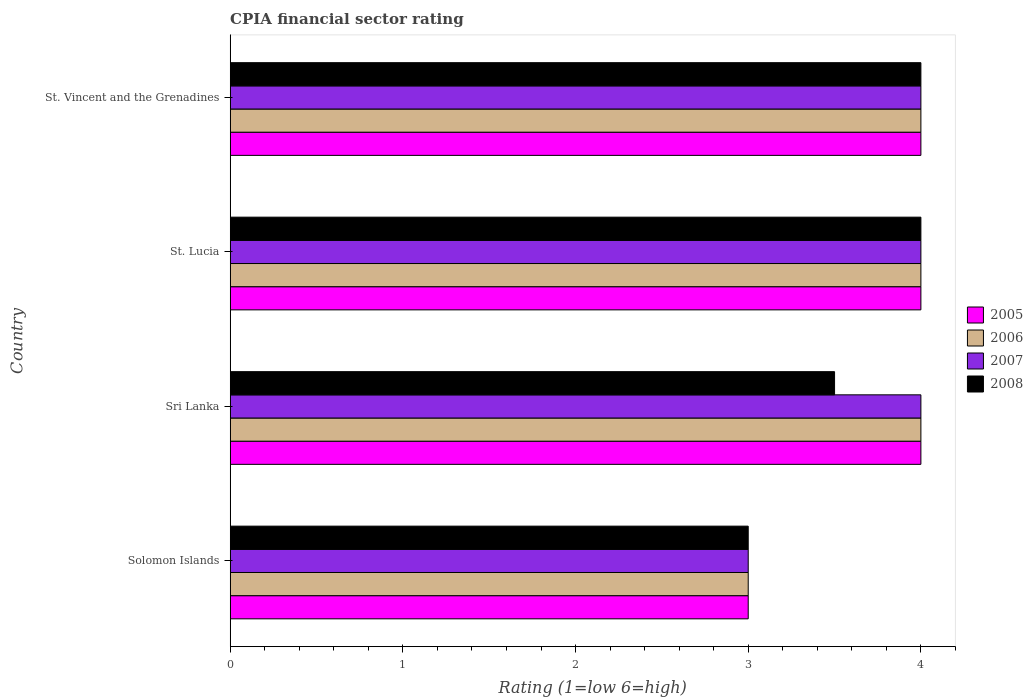Are the number of bars per tick equal to the number of legend labels?
Your response must be concise. Yes. How many bars are there on the 3rd tick from the top?
Your answer should be compact. 4. What is the label of the 2nd group of bars from the top?
Provide a short and direct response. St. Lucia. In how many cases, is the number of bars for a given country not equal to the number of legend labels?
Provide a succinct answer. 0. What is the CPIA rating in 2007 in St. Vincent and the Grenadines?
Provide a succinct answer. 4. In which country was the CPIA rating in 2008 maximum?
Ensure brevity in your answer.  St. Lucia. In which country was the CPIA rating in 2007 minimum?
Give a very brief answer. Solomon Islands. What is the average CPIA rating in 2006 per country?
Provide a short and direct response. 3.75. What is the difference between the CPIA rating in 2005 and CPIA rating in 2008 in St. Vincent and the Grenadines?
Keep it short and to the point. 0. In how many countries, is the CPIA rating in 2006 greater than 2.2 ?
Ensure brevity in your answer.  4. Is the CPIA rating in 2006 in Solomon Islands less than that in Sri Lanka?
Keep it short and to the point. Yes. Is the difference between the CPIA rating in 2005 in St. Lucia and St. Vincent and the Grenadines greater than the difference between the CPIA rating in 2008 in St. Lucia and St. Vincent and the Grenadines?
Your response must be concise. No. What is the difference between the highest and the second highest CPIA rating in 2006?
Offer a terse response. 0. What is the difference between the highest and the lowest CPIA rating in 2008?
Your answer should be very brief. 1. Is the sum of the CPIA rating in 2005 in Solomon Islands and Sri Lanka greater than the maximum CPIA rating in 2006 across all countries?
Give a very brief answer. Yes. Is it the case that in every country, the sum of the CPIA rating in 2006 and CPIA rating in 2008 is greater than the sum of CPIA rating in 2007 and CPIA rating in 2005?
Ensure brevity in your answer.  No. What does the 4th bar from the bottom in St. Lucia represents?
Provide a short and direct response. 2008. How many bars are there?
Your response must be concise. 16. Are all the bars in the graph horizontal?
Offer a very short reply. Yes. How many countries are there in the graph?
Provide a succinct answer. 4. What is the difference between two consecutive major ticks on the X-axis?
Your answer should be compact. 1. Where does the legend appear in the graph?
Your response must be concise. Center right. How many legend labels are there?
Ensure brevity in your answer.  4. What is the title of the graph?
Offer a terse response. CPIA financial sector rating. Does "2002" appear as one of the legend labels in the graph?
Your answer should be compact. No. What is the label or title of the X-axis?
Make the answer very short. Rating (1=low 6=high). What is the Rating (1=low 6=high) in 2005 in Solomon Islands?
Give a very brief answer. 3. What is the Rating (1=low 6=high) of 2006 in Solomon Islands?
Provide a succinct answer. 3. What is the Rating (1=low 6=high) in 2007 in Solomon Islands?
Offer a terse response. 3. What is the Rating (1=low 6=high) in 2006 in Sri Lanka?
Give a very brief answer. 4. What is the Rating (1=low 6=high) of 2005 in St. Lucia?
Make the answer very short. 4. What is the Rating (1=low 6=high) of 2007 in St. Lucia?
Offer a very short reply. 4. What is the Rating (1=low 6=high) in 2006 in St. Vincent and the Grenadines?
Your answer should be very brief. 4. What is the Rating (1=low 6=high) of 2007 in St. Vincent and the Grenadines?
Offer a very short reply. 4. Across all countries, what is the maximum Rating (1=low 6=high) in 2006?
Your answer should be compact. 4. Across all countries, what is the maximum Rating (1=low 6=high) in 2007?
Ensure brevity in your answer.  4. Across all countries, what is the maximum Rating (1=low 6=high) of 2008?
Offer a terse response. 4. Across all countries, what is the minimum Rating (1=low 6=high) of 2005?
Keep it short and to the point. 3. Across all countries, what is the minimum Rating (1=low 6=high) of 2006?
Your response must be concise. 3. Across all countries, what is the minimum Rating (1=low 6=high) of 2008?
Your answer should be compact. 3. What is the total Rating (1=low 6=high) of 2006 in the graph?
Ensure brevity in your answer.  15. What is the difference between the Rating (1=low 6=high) of 2006 in Solomon Islands and that in Sri Lanka?
Keep it short and to the point. -1. What is the difference between the Rating (1=low 6=high) in 2007 in Solomon Islands and that in St. Lucia?
Make the answer very short. -1. What is the difference between the Rating (1=low 6=high) of 2007 in Solomon Islands and that in St. Vincent and the Grenadines?
Offer a terse response. -1. What is the difference between the Rating (1=low 6=high) of 2007 in Sri Lanka and that in St. Lucia?
Offer a very short reply. 0. What is the difference between the Rating (1=low 6=high) of 2008 in Sri Lanka and that in St. Lucia?
Keep it short and to the point. -0.5. What is the difference between the Rating (1=low 6=high) in 2005 in Sri Lanka and that in St. Vincent and the Grenadines?
Ensure brevity in your answer.  0. What is the difference between the Rating (1=low 6=high) in 2007 in Sri Lanka and that in St. Vincent and the Grenadines?
Ensure brevity in your answer.  0. What is the difference between the Rating (1=low 6=high) of 2008 in Sri Lanka and that in St. Vincent and the Grenadines?
Make the answer very short. -0.5. What is the difference between the Rating (1=low 6=high) of 2007 in St. Lucia and that in St. Vincent and the Grenadines?
Your answer should be compact. 0. What is the difference between the Rating (1=low 6=high) in 2008 in St. Lucia and that in St. Vincent and the Grenadines?
Give a very brief answer. 0. What is the difference between the Rating (1=low 6=high) of 2005 in Solomon Islands and the Rating (1=low 6=high) of 2007 in Sri Lanka?
Your answer should be very brief. -1. What is the difference between the Rating (1=low 6=high) in 2005 in Solomon Islands and the Rating (1=low 6=high) in 2008 in Sri Lanka?
Ensure brevity in your answer.  -0.5. What is the difference between the Rating (1=low 6=high) of 2006 in Solomon Islands and the Rating (1=low 6=high) of 2008 in Sri Lanka?
Make the answer very short. -0.5. What is the difference between the Rating (1=low 6=high) of 2005 in Solomon Islands and the Rating (1=low 6=high) of 2007 in St. Lucia?
Keep it short and to the point. -1. What is the difference between the Rating (1=low 6=high) of 2006 in Solomon Islands and the Rating (1=low 6=high) of 2007 in St. Lucia?
Your response must be concise. -1. What is the difference between the Rating (1=low 6=high) in 2007 in Solomon Islands and the Rating (1=low 6=high) in 2008 in St. Lucia?
Give a very brief answer. -1. What is the difference between the Rating (1=low 6=high) of 2005 in Solomon Islands and the Rating (1=low 6=high) of 2007 in St. Vincent and the Grenadines?
Ensure brevity in your answer.  -1. What is the difference between the Rating (1=low 6=high) of 2007 in Solomon Islands and the Rating (1=low 6=high) of 2008 in St. Vincent and the Grenadines?
Offer a terse response. -1. What is the difference between the Rating (1=low 6=high) in 2005 in Sri Lanka and the Rating (1=low 6=high) in 2006 in St. Lucia?
Ensure brevity in your answer.  0. What is the difference between the Rating (1=low 6=high) in 2005 in Sri Lanka and the Rating (1=low 6=high) in 2007 in St. Lucia?
Provide a succinct answer. 0. What is the difference between the Rating (1=low 6=high) of 2006 in Sri Lanka and the Rating (1=low 6=high) of 2007 in St. Lucia?
Provide a short and direct response. 0. What is the difference between the Rating (1=low 6=high) in 2006 in Sri Lanka and the Rating (1=low 6=high) in 2008 in St. Vincent and the Grenadines?
Provide a succinct answer. 0. What is the difference between the Rating (1=low 6=high) in 2005 in St. Lucia and the Rating (1=low 6=high) in 2006 in St. Vincent and the Grenadines?
Give a very brief answer. 0. What is the difference between the Rating (1=low 6=high) of 2006 in St. Lucia and the Rating (1=low 6=high) of 2008 in St. Vincent and the Grenadines?
Offer a terse response. 0. What is the average Rating (1=low 6=high) in 2005 per country?
Offer a terse response. 3.75. What is the average Rating (1=low 6=high) of 2006 per country?
Offer a terse response. 3.75. What is the average Rating (1=low 6=high) in 2007 per country?
Make the answer very short. 3.75. What is the average Rating (1=low 6=high) of 2008 per country?
Offer a very short reply. 3.62. What is the difference between the Rating (1=low 6=high) in 2005 and Rating (1=low 6=high) in 2007 in Solomon Islands?
Your answer should be compact. 0. What is the difference between the Rating (1=low 6=high) in 2005 and Rating (1=low 6=high) in 2008 in Solomon Islands?
Your answer should be compact. 0. What is the difference between the Rating (1=low 6=high) of 2006 and Rating (1=low 6=high) of 2007 in Solomon Islands?
Give a very brief answer. 0. What is the difference between the Rating (1=low 6=high) in 2007 and Rating (1=low 6=high) in 2008 in Solomon Islands?
Make the answer very short. 0. What is the difference between the Rating (1=low 6=high) of 2005 and Rating (1=low 6=high) of 2006 in Sri Lanka?
Provide a succinct answer. 0. What is the difference between the Rating (1=low 6=high) in 2006 and Rating (1=low 6=high) in 2008 in Sri Lanka?
Offer a very short reply. 0.5. What is the difference between the Rating (1=low 6=high) in 2007 and Rating (1=low 6=high) in 2008 in Sri Lanka?
Your answer should be very brief. 0.5. What is the difference between the Rating (1=low 6=high) in 2007 and Rating (1=low 6=high) in 2008 in St. Lucia?
Ensure brevity in your answer.  0. What is the difference between the Rating (1=low 6=high) of 2005 and Rating (1=low 6=high) of 2006 in St. Vincent and the Grenadines?
Make the answer very short. 0. What is the difference between the Rating (1=low 6=high) in 2005 and Rating (1=low 6=high) in 2007 in St. Vincent and the Grenadines?
Make the answer very short. 0. What is the difference between the Rating (1=low 6=high) of 2005 and Rating (1=low 6=high) of 2008 in St. Vincent and the Grenadines?
Keep it short and to the point. 0. What is the ratio of the Rating (1=low 6=high) of 2005 in Solomon Islands to that in Sri Lanka?
Offer a terse response. 0.75. What is the ratio of the Rating (1=low 6=high) of 2006 in Solomon Islands to that in Sri Lanka?
Your response must be concise. 0.75. What is the ratio of the Rating (1=low 6=high) in 2007 in Solomon Islands to that in Sri Lanka?
Offer a terse response. 0.75. What is the ratio of the Rating (1=low 6=high) in 2005 in Solomon Islands to that in St. Lucia?
Your response must be concise. 0.75. What is the ratio of the Rating (1=low 6=high) of 2008 in Solomon Islands to that in St. Vincent and the Grenadines?
Provide a short and direct response. 0.75. What is the ratio of the Rating (1=low 6=high) of 2005 in Sri Lanka to that in St. Lucia?
Offer a very short reply. 1. What is the ratio of the Rating (1=low 6=high) in 2006 in Sri Lanka to that in St. Lucia?
Ensure brevity in your answer.  1. What is the ratio of the Rating (1=low 6=high) of 2008 in Sri Lanka to that in St. Lucia?
Your response must be concise. 0.88. What is the ratio of the Rating (1=low 6=high) in 2006 in Sri Lanka to that in St. Vincent and the Grenadines?
Provide a short and direct response. 1. What is the ratio of the Rating (1=low 6=high) of 2008 in Sri Lanka to that in St. Vincent and the Grenadines?
Offer a terse response. 0.88. What is the ratio of the Rating (1=low 6=high) in 2005 in St. Lucia to that in St. Vincent and the Grenadines?
Your answer should be compact. 1. What is the ratio of the Rating (1=low 6=high) of 2007 in St. Lucia to that in St. Vincent and the Grenadines?
Your answer should be compact. 1. What is the ratio of the Rating (1=low 6=high) of 2008 in St. Lucia to that in St. Vincent and the Grenadines?
Offer a very short reply. 1. What is the difference between the highest and the second highest Rating (1=low 6=high) of 2005?
Make the answer very short. 0. What is the difference between the highest and the second highest Rating (1=low 6=high) of 2006?
Offer a very short reply. 0. What is the difference between the highest and the second highest Rating (1=low 6=high) of 2008?
Offer a terse response. 0. What is the difference between the highest and the lowest Rating (1=low 6=high) of 2006?
Offer a very short reply. 1. What is the difference between the highest and the lowest Rating (1=low 6=high) in 2007?
Give a very brief answer. 1. What is the difference between the highest and the lowest Rating (1=low 6=high) in 2008?
Your answer should be compact. 1. 